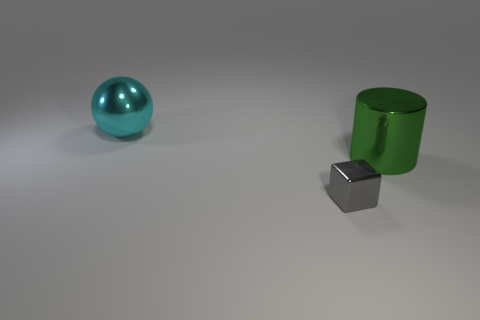What materials could these objects be made of in the real world? The turquoise sphere has a glossy, reflective surface that could be similar to polished metal or glass. The green cylinder looks like it could be made of colored plastic or painted metal, due to its matte finish. The small gray cube's reflective nature suggests a material like polished steel or silver. 